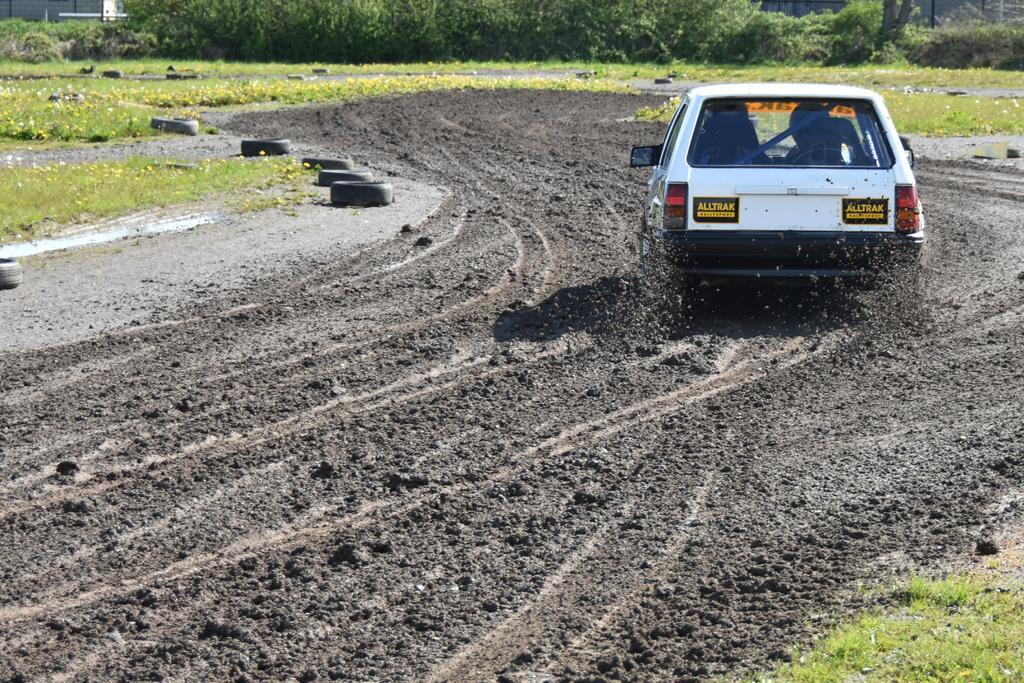What is the main subject of the image? The main subject of the image is a car. Where is the car located in the image? The car is on a mud land. What can be seen in the background of the image? There is grass and trees in the background of the image. How much money does the stranger in the image have? There is no stranger present in the image, so it is not possible to determine how much money they might have. 